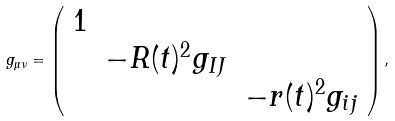Convert formula to latex. <formula><loc_0><loc_0><loc_500><loc_500>g _ { \mu \nu } = \left ( \begin{array} { c c c } 1 \\ & - R ( t ) ^ { 2 } g _ { I J } \\ & & - r ( t ) ^ { 2 } g _ { i j } \\ \end{array} \right ) ,</formula> 